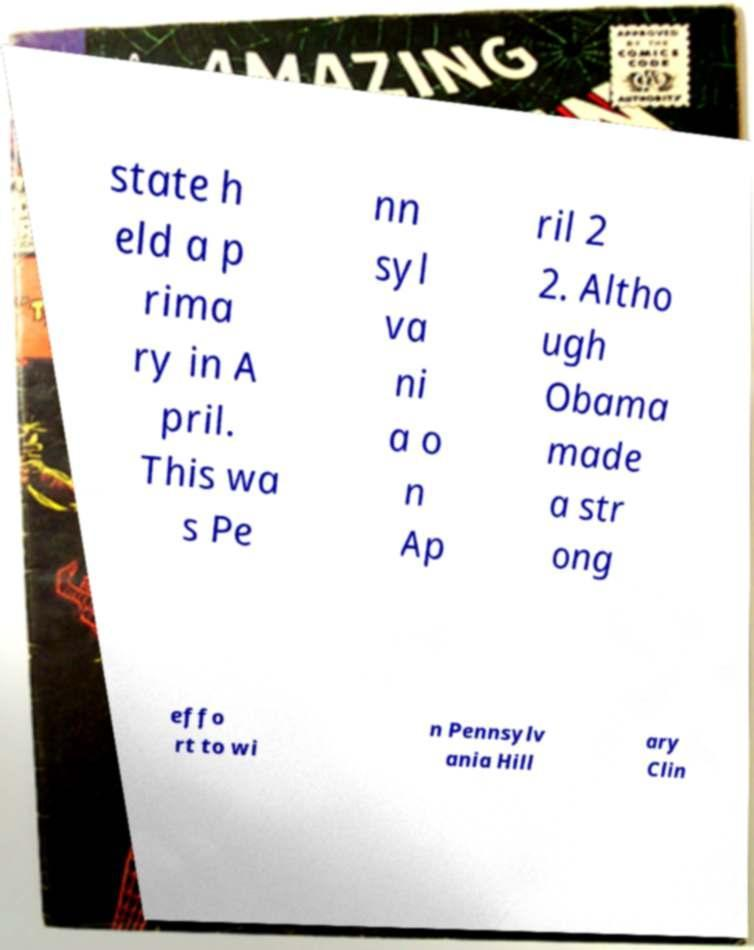What messages or text are displayed in this image? I need them in a readable, typed format. state h eld a p rima ry in A pril. This wa s Pe nn syl va ni a o n Ap ril 2 2. Altho ugh Obama made a str ong effo rt to wi n Pennsylv ania Hill ary Clin 